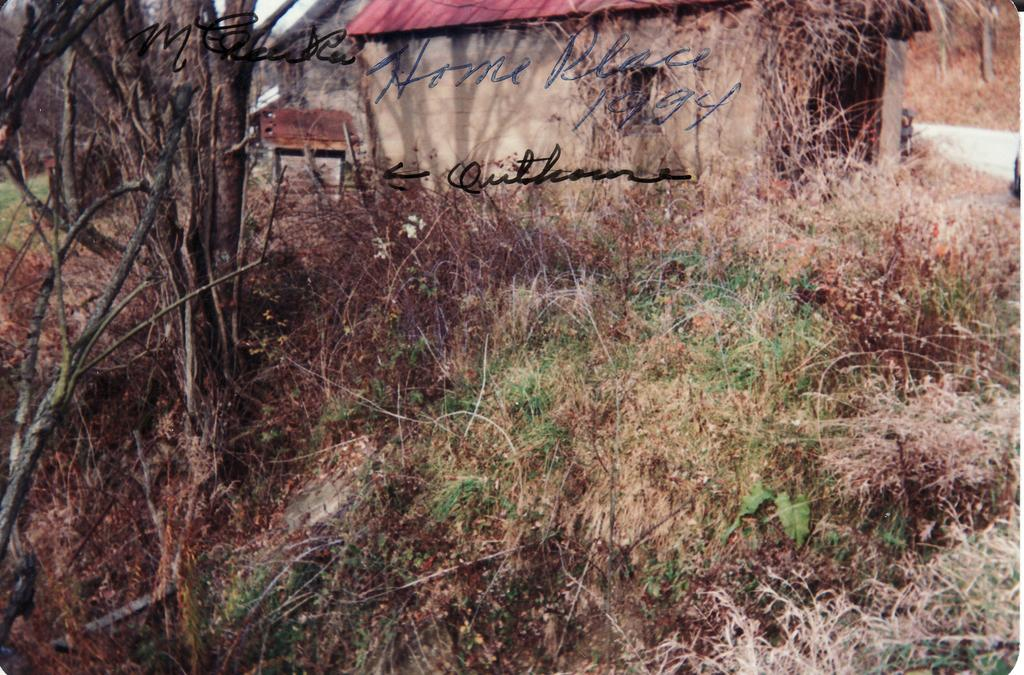What type of vegetation is on the left side of the image? There are trees on the left side of the image. What type of structures are in the middle of the image? There are houses in the middle of the image. What else can be seen in the image besides trees and houses? There is text present in the image. What type of produce can be seen hanging from the trees in the image? There is no produce visible in the image. 